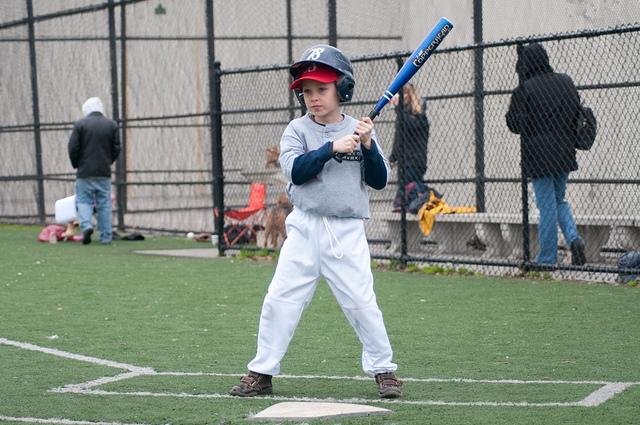Is it cold outside?
Write a very short answer. Yes. Whether the kid holding a bat?
Answer briefly. Yes. Does the little boys shoes have shoe strings?
Be succinct. No. Is this a major league baseball player?
Answer briefly. No. 